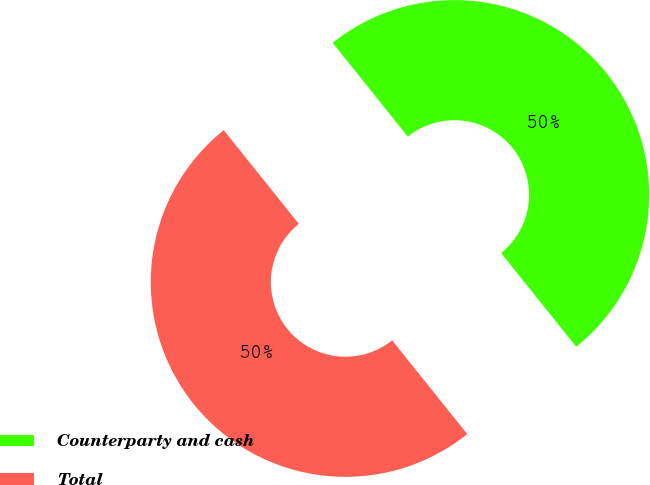Convert chart. <chart><loc_0><loc_0><loc_500><loc_500><pie_chart><fcel>Counterparty and cash<fcel>Total<nl><fcel>50.0%<fcel>50.0%<nl></chart> 